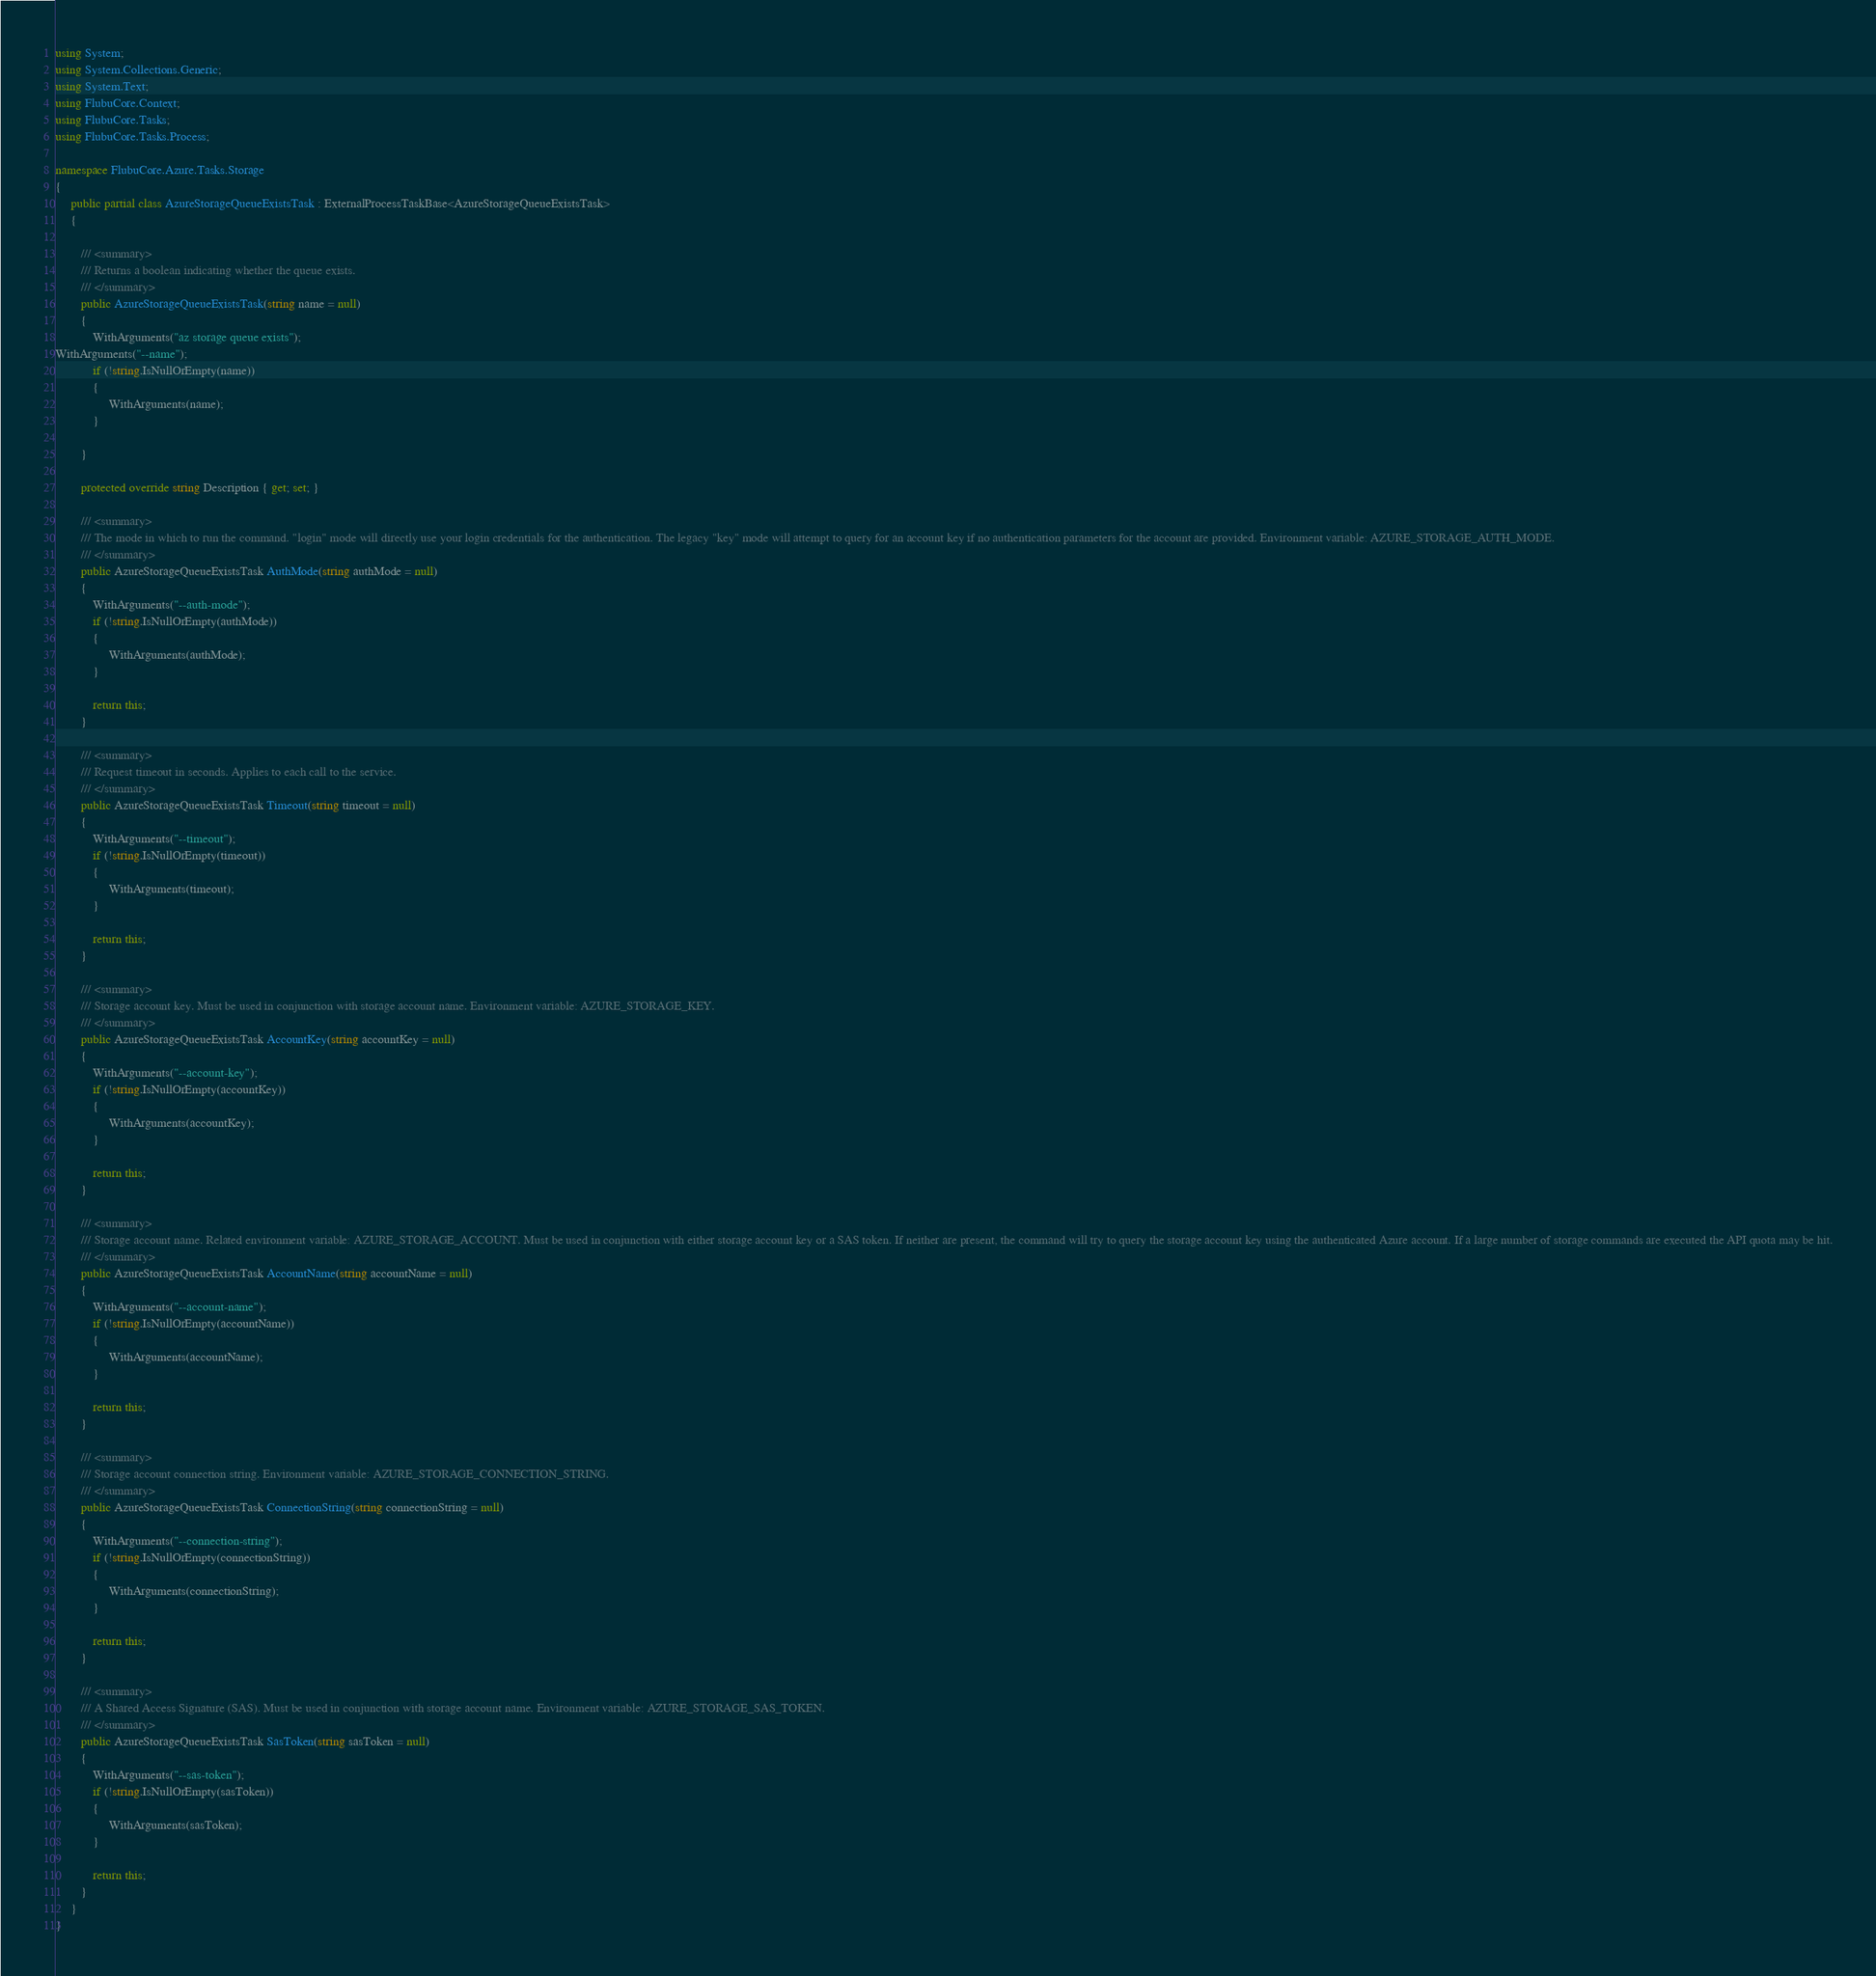<code> <loc_0><loc_0><loc_500><loc_500><_C#_>
using System;
using System.Collections.Generic;
using System.Text;
using FlubuCore.Context;
using FlubuCore.Tasks;
using FlubuCore.Tasks.Process;

namespace FlubuCore.Azure.Tasks.Storage
{
     public partial class AzureStorageQueueExistsTask : ExternalProcessTaskBase<AzureStorageQueueExistsTask>
     {
        
        /// <summary>
        /// Returns a boolean indicating whether the queue exists.
        /// </summary>
        public AzureStorageQueueExistsTask(string name = null)
        {
            WithArguments("az storage queue exists");
WithArguments("--name");
            if (!string.IsNullOrEmpty(name))
            {
                 WithArguments(name);
            }

        }

        protected override string Description { get; set; }
        
        /// <summary>
        /// The mode in which to run the command. "login" mode will directly use your login credentials for the authentication. The legacy "key" mode will attempt to query for an account key if no authentication parameters for the account are provided. Environment variable: AZURE_STORAGE_AUTH_MODE.
        /// </summary>
        public AzureStorageQueueExistsTask AuthMode(string authMode = null)
        {
            WithArguments("--auth-mode");
            if (!string.IsNullOrEmpty(authMode))
            {
                 WithArguments(authMode);
            }

            return this;
        }

        /// <summary>
        /// Request timeout in seconds. Applies to each call to the service.
        /// </summary>
        public AzureStorageQueueExistsTask Timeout(string timeout = null)
        {
            WithArguments("--timeout");
            if (!string.IsNullOrEmpty(timeout))
            {
                 WithArguments(timeout);
            }

            return this;
        }

        /// <summary>
        /// Storage account key. Must be used in conjunction with storage account name. Environment variable: AZURE_STORAGE_KEY.
        /// </summary>
        public AzureStorageQueueExistsTask AccountKey(string accountKey = null)
        {
            WithArguments("--account-key");
            if (!string.IsNullOrEmpty(accountKey))
            {
                 WithArguments(accountKey);
            }

            return this;
        }

        /// <summary>
        /// Storage account name. Related environment variable: AZURE_STORAGE_ACCOUNT. Must be used in conjunction with either storage account key or a SAS token. If neither are present, the command will try to query the storage account key using the authenticated Azure account. If a large number of storage commands are executed the API quota may be hit.
        /// </summary>
        public AzureStorageQueueExistsTask AccountName(string accountName = null)
        {
            WithArguments("--account-name");
            if (!string.IsNullOrEmpty(accountName))
            {
                 WithArguments(accountName);
            }

            return this;
        }

        /// <summary>
        /// Storage account connection string. Environment variable: AZURE_STORAGE_CONNECTION_STRING.
        /// </summary>
        public AzureStorageQueueExistsTask ConnectionString(string connectionString = null)
        {
            WithArguments("--connection-string");
            if (!string.IsNullOrEmpty(connectionString))
            {
                 WithArguments(connectionString);
            }

            return this;
        }

        /// <summary>
        /// A Shared Access Signature (SAS). Must be used in conjunction with storage account name. Environment variable: AZURE_STORAGE_SAS_TOKEN.
        /// </summary>
        public AzureStorageQueueExistsTask SasToken(string sasToken = null)
        {
            WithArguments("--sas-token");
            if (!string.IsNullOrEmpty(sasToken))
            {
                 WithArguments(sasToken);
            }

            return this;
        }
     }
}
</code> 